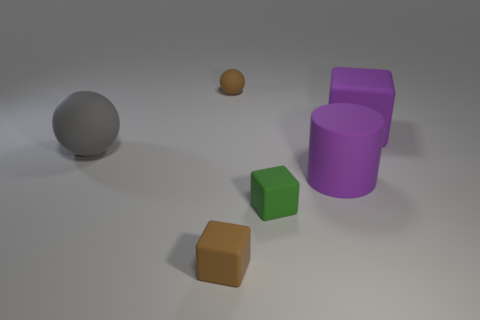Add 4 large brown matte cylinders. How many objects exist? 10 Subtract all spheres. How many objects are left? 4 Add 2 large gray shiny cylinders. How many large gray shiny cylinders exist? 2 Subtract 0 cyan blocks. How many objects are left? 6 Subtract all big gray cylinders. Subtract all large purple cubes. How many objects are left? 5 Add 5 small green things. How many small green things are left? 6 